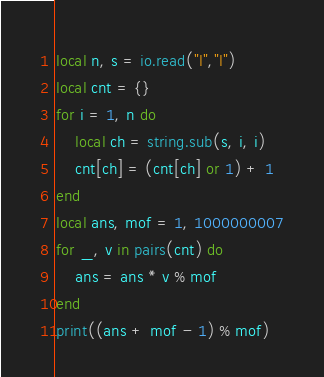Convert code to text. <code><loc_0><loc_0><loc_500><loc_500><_Lua_>local n, s = io.read("l","l")
local cnt = {}
for i = 1, n do
    local ch = string.sub(s, i, i)
    cnt[ch] = (cnt[ch] or 1) + 1
end
local ans, mof = 1, 1000000007
for _, v in pairs(cnt) do
    ans = ans * v % mof
end
print((ans + mof - 1) % mof)
</code> 